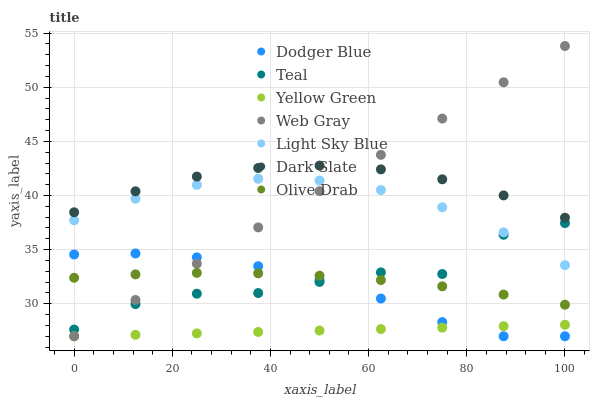Does Yellow Green have the minimum area under the curve?
Answer yes or no. Yes. Does Dark Slate have the maximum area under the curve?
Answer yes or no. Yes. Does Dark Slate have the minimum area under the curve?
Answer yes or no. No. Does Yellow Green have the maximum area under the curve?
Answer yes or no. No. Is Yellow Green the smoothest?
Answer yes or no. Yes. Is Teal the roughest?
Answer yes or no. Yes. Is Dark Slate the smoothest?
Answer yes or no. No. Is Dark Slate the roughest?
Answer yes or no. No. Does Web Gray have the lowest value?
Answer yes or no. Yes. Does Dark Slate have the lowest value?
Answer yes or no. No. Does Web Gray have the highest value?
Answer yes or no. Yes. Does Dark Slate have the highest value?
Answer yes or no. No. Is Yellow Green less than Olive Drab?
Answer yes or no. Yes. Is Light Sky Blue greater than Olive Drab?
Answer yes or no. Yes. Does Yellow Green intersect Web Gray?
Answer yes or no. Yes. Is Yellow Green less than Web Gray?
Answer yes or no. No. Is Yellow Green greater than Web Gray?
Answer yes or no. No. Does Yellow Green intersect Olive Drab?
Answer yes or no. No. 